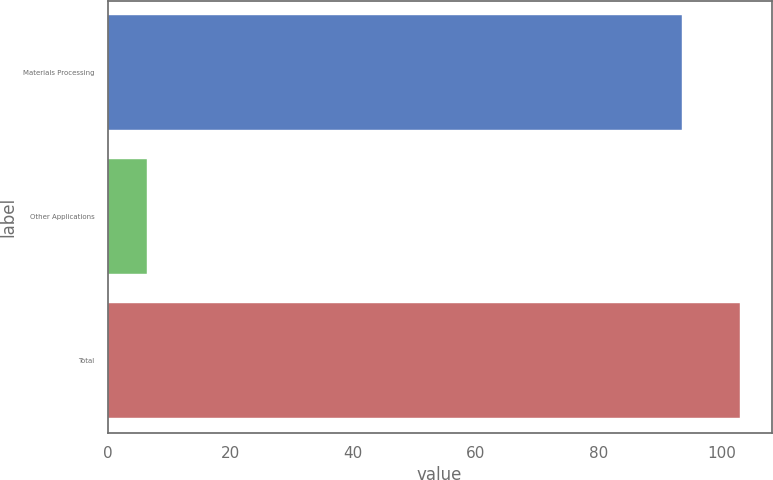Convert chart to OTSL. <chart><loc_0><loc_0><loc_500><loc_500><bar_chart><fcel>Materials Processing<fcel>Other Applications<fcel>Total<nl><fcel>93.6<fcel>6.4<fcel>102.96<nl></chart> 